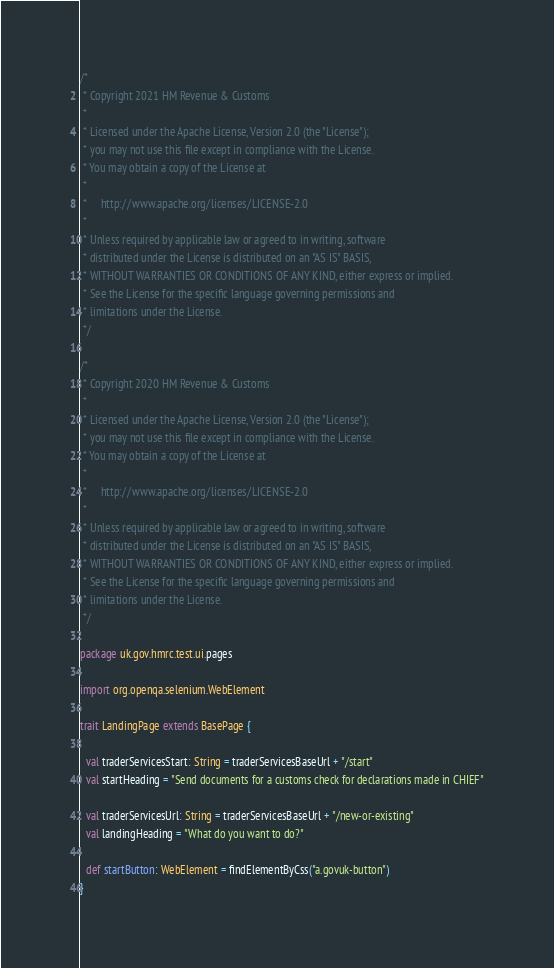Convert code to text. <code><loc_0><loc_0><loc_500><loc_500><_Scala_>/*
 * Copyright 2021 HM Revenue & Customs
 *
 * Licensed under the Apache License, Version 2.0 (the "License");
 * you may not use this file except in compliance with the License.
 * You may obtain a copy of the License at
 *
 *     http://www.apache.org/licenses/LICENSE-2.0
 *
 * Unless required by applicable law or agreed to in writing, software
 * distributed under the License is distributed on an "AS IS" BASIS,
 * WITHOUT WARRANTIES OR CONDITIONS OF ANY KIND, either express or implied.
 * See the License for the specific language governing permissions and
 * limitations under the License.
 */

/*
 * Copyright 2020 HM Revenue & Customs
 *
 * Licensed under the Apache License, Version 2.0 (the "License");
 * you may not use this file except in compliance with the License.
 * You may obtain a copy of the License at
 *
 *     http://www.apache.org/licenses/LICENSE-2.0
 *
 * Unless required by applicable law or agreed to in writing, software
 * distributed under the License is distributed on an "AS IS" BASIS,
 * WITHOUT WARRANTIES OR CONDITIONS OF ANY KIND, either express or implied.
 * See the License for the specific language governing permissions and
 * limitations under the License.
 */

package uk.gov.hmrc.test.ui.pages

import org.openqa.selenium.WebElement

trait LandingPage extends BasePage {

  val traderServicesStart: String = traderServicesBaseUrl + "/start"
  val startHeading = "Send documents for a customs check for declarations made in CHIEF"

  val traderServicesUrl: String = traderServicesBaseUrl + "/new-or-existing"
  val landingHeading = "What do you want to do?"

  def startButton: WebElement = findElementByCss("a.govuk-button")
}</code> 